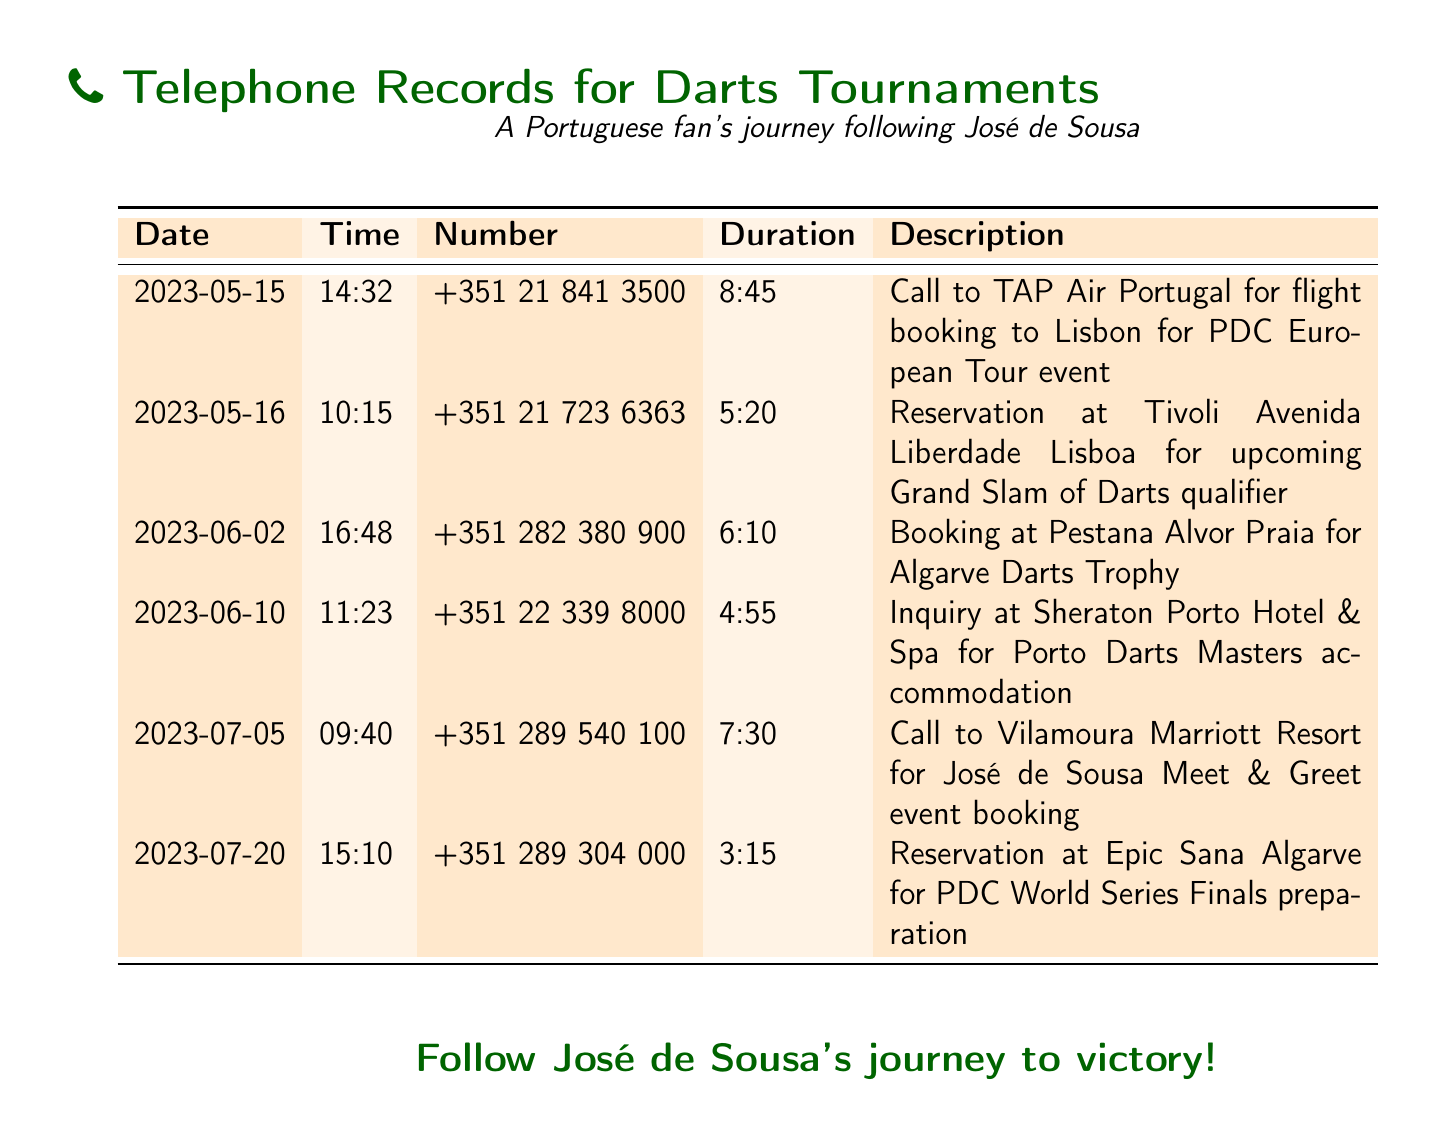What is the date of the first call? The date of the first call listed in the document is 2023-05-15.
Answer: 2023-05-15 Who was called for the flight booking to Lisbon? The call was made to TAP Air Portugal for flight booking to Lisbon.
Answer: TAP Air Portugal What was the duration of the call to Vilamoura Marriott Resort? The duration of the call to Vilamoura Marriott Resort for the José de Sousa Meet & Greet event was 7 minutes and 30 seconds.
Answer: 7:30 How many calls were made in July? There were two calls made in July: one on July 5 and another on July 20.
Answer: 2 Which hotel was booked for the Algarve Darts Trophy? Pestana Alvor Praia was booked for the Algarve Darts Trophy.
Answer: Pestana Alvor Praia What time was the call placed to inquire about the Sheraton Porto Hotel? The call to inquire about the Sheraton Porto Hotel was placed at 11:23.
Answer: 11:23 What is the total duration of all calls listed? The total duration of the calls is obtained by adding up all individual durations: 8:45 + 5:20 + 6:10 + 4:55 + 7:30 + 3:15, equaling approximately 35 minutes and 55 seconds.
Answer: 35:55 What was the purpose of the call on June 10? The purpose of the call on June 10 was to make an inquiry about accommodation for the Porto Darts Masters.
Answer: Inquiry at Sheraton Porto Hotel & Spa What is the description of the last call made? The last call made was for a reservation at Epic Sana Algarve for PDC World Series Finals preparation.
Answer: Reservation at Epic Sana Algarve for PDC World Series Finals preparation 